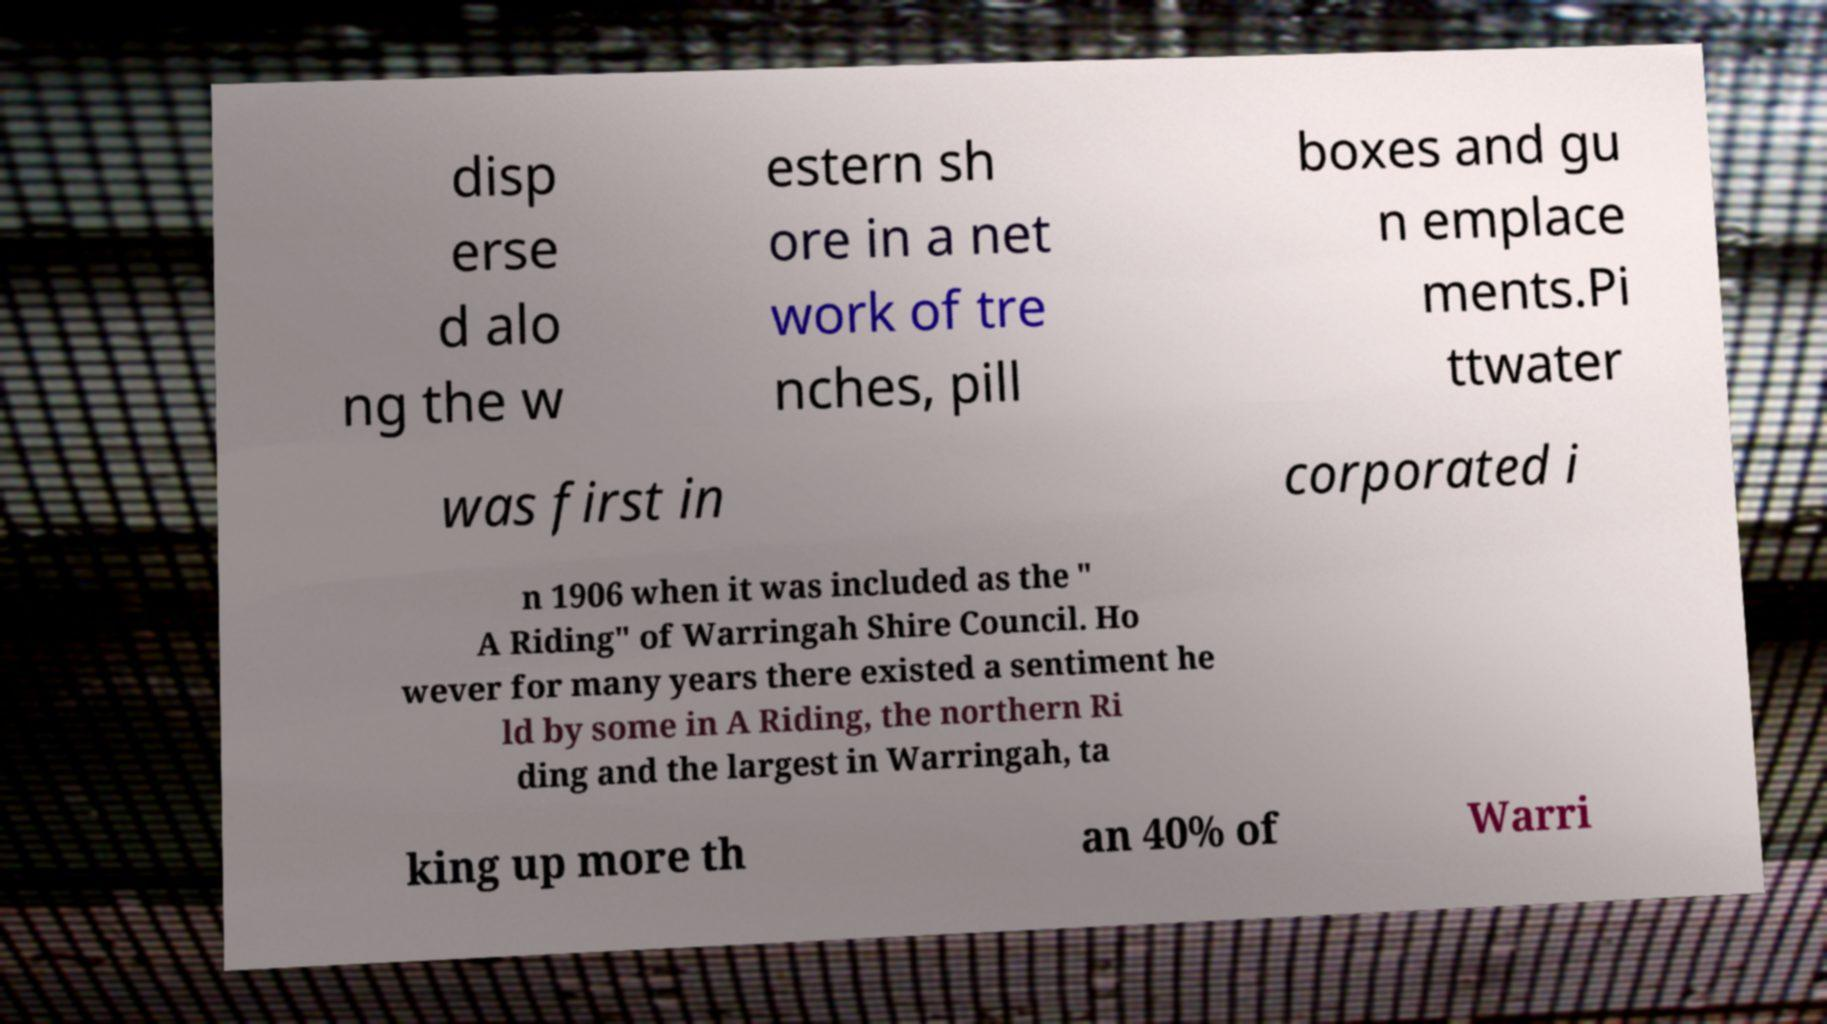I need the written content from this picture converted into text. Can you do that? disp erse d alo ng the w estern sh ore in a net work of tre nches, pill boxes and gu n emplace ments.Pi ttwater was first in corporated i n 1906 when it was included as the " A Riding" of Warringah Shire Council. Ho wever for many years there existed a sentiment he ld by some in A Riding, the northern Ri ding and the largest in Warringah, ta king up more th an 40% of Warri 